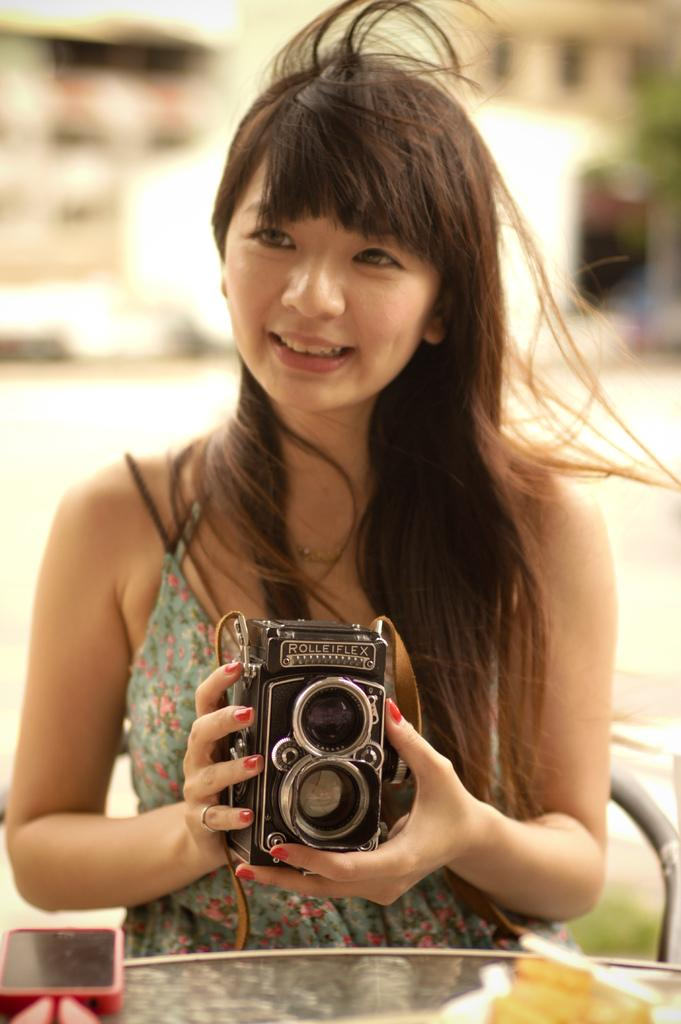Who is the main subject in the image? There is a woman in the image. What is the woman doing in the image? The woman is sitting on a chair and holding a camera. What else can be seen on the table in the image? There is a mobile on the table. Are there any cobwebs visible in the image? There is no mention of cobwebs in the provided facts, and therefore we cannot determine if any are present in the image. 